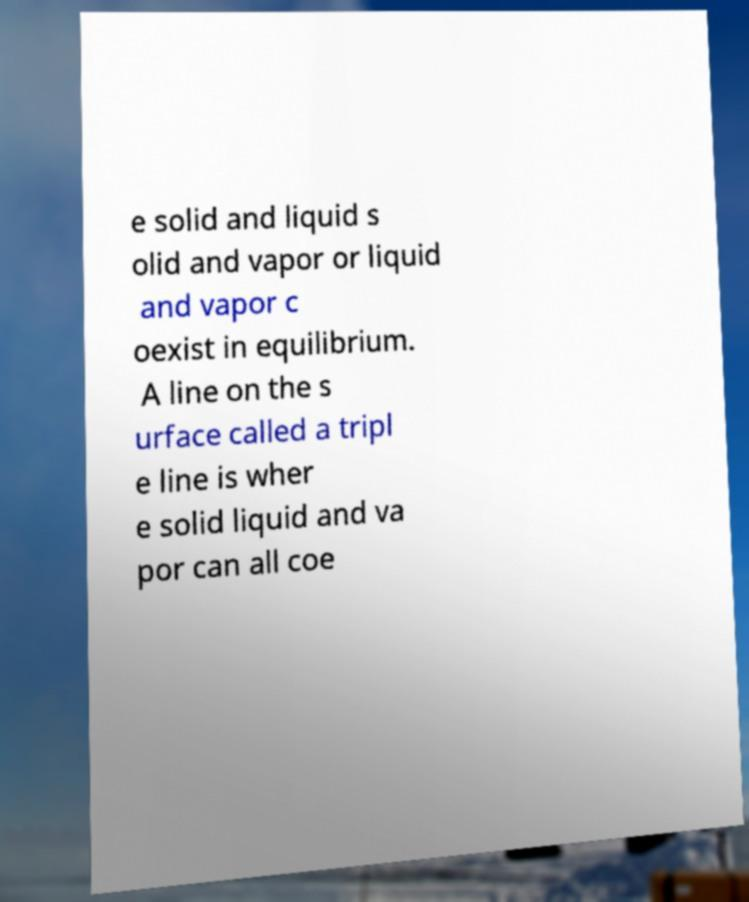Please identify and transcribe the text found in this image. e solid and liquid s olid and vapor or liquid and vapor c oexist in equilibrium. A line on the s urface called a tripl e line is wher e solid liquid and va por can all coe 